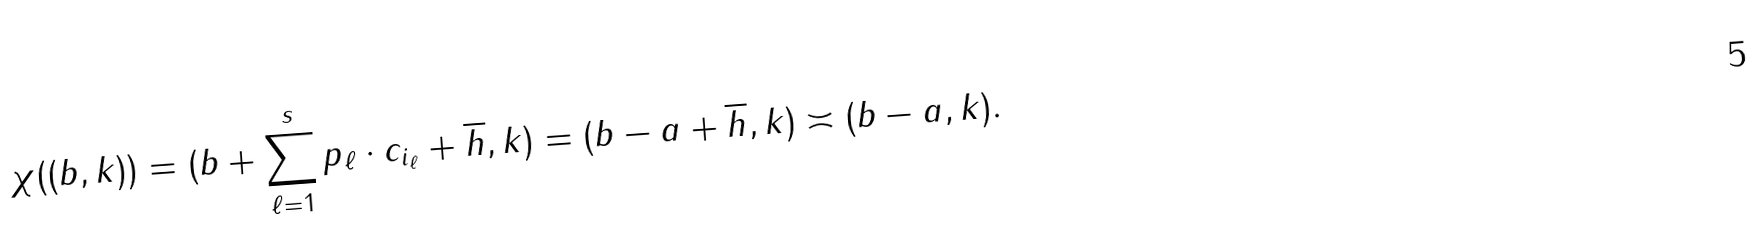<formula> <loc_0><loc_0><loc_500><loc_500>\chi ( ( b , k ) ) = ( b + \sum _ { \ell = 1 } ^ { s } p _ { \ell } \cdot c _ { i _ { \ell } } + \overline { h } , k ) = ( b - a + \overline { h } , k ) \asymp ( b - a , k ) .</formula> 